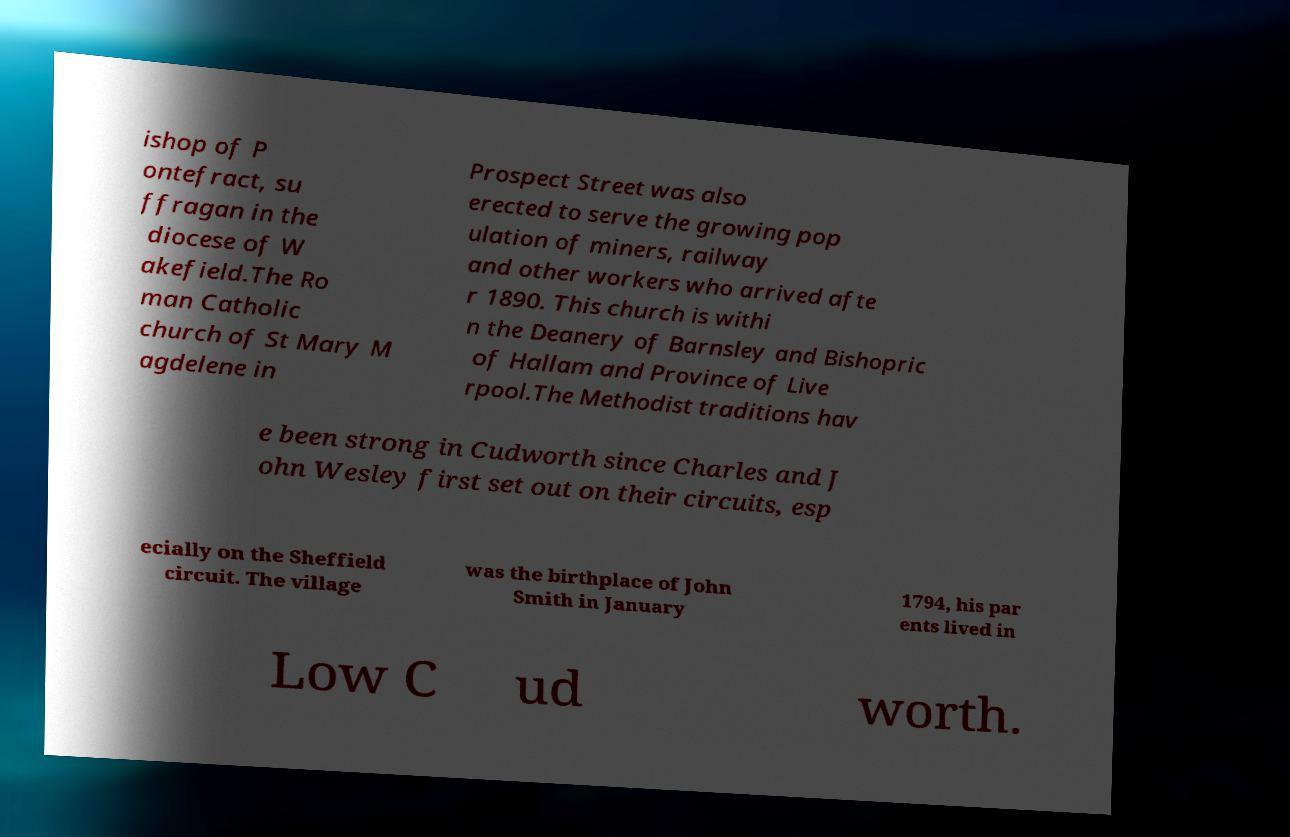For documentation purposes, I need the text within this image transcribed. Could you provide that? ishop of P ontefract, su ffragan in the diocese of W akefield.The Ro man Catholic church of St Mary M agdelene in Prospect Street was also erected to serve the growing pop ulation of miners, railway and other workers who arrived afte r 1890. This church is withi n the Deanery of Barnsley and Bishopric of Hallam and Province of Live rpool.The Methodist traditions hav e been strong in Cudworth since Charles and J ohn Wesley first set out on their circuits, esp ecially on the Sheffield circuit. The village was the birthplace of John Smith in January 1794, his par ents lived in Low C ud worth. 